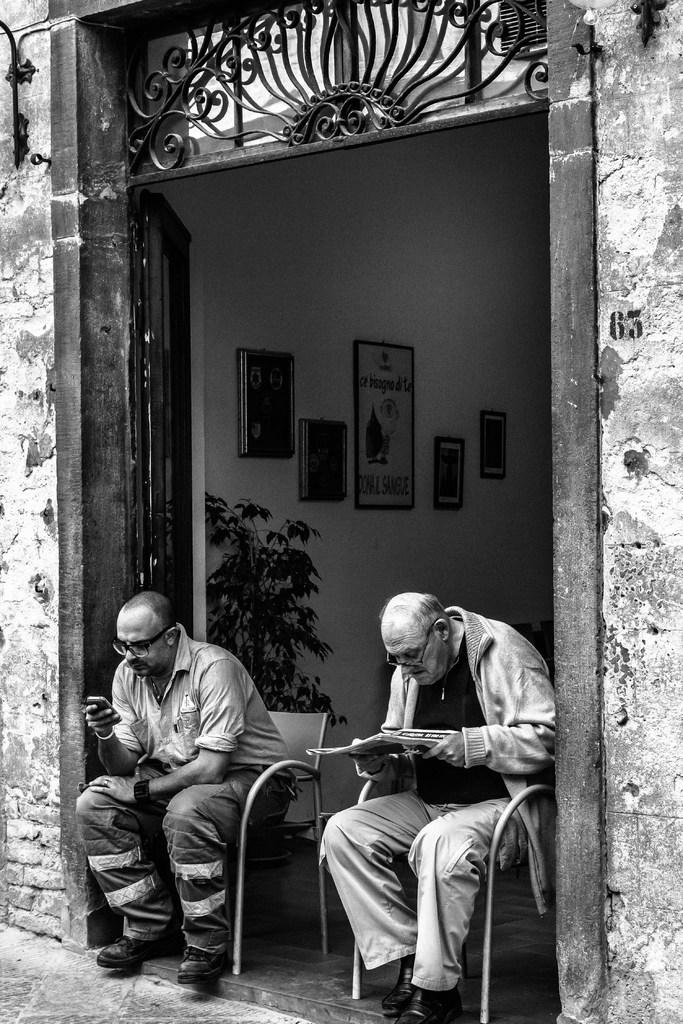What is the color scheme of the image? The image is black and white. What is the person in the image doing? The person is sitting on chairs in the image. What type of architectural feature can be seen in the image? There is a door and a wall in the image. What type of vegetation is present in the image? There are plants in the image. What type of decorative items are present in the image? There are photo frames in the image. Can you point out the error in the image? There is no error present in the image, as it is a clear and accurate representation of the scene. 